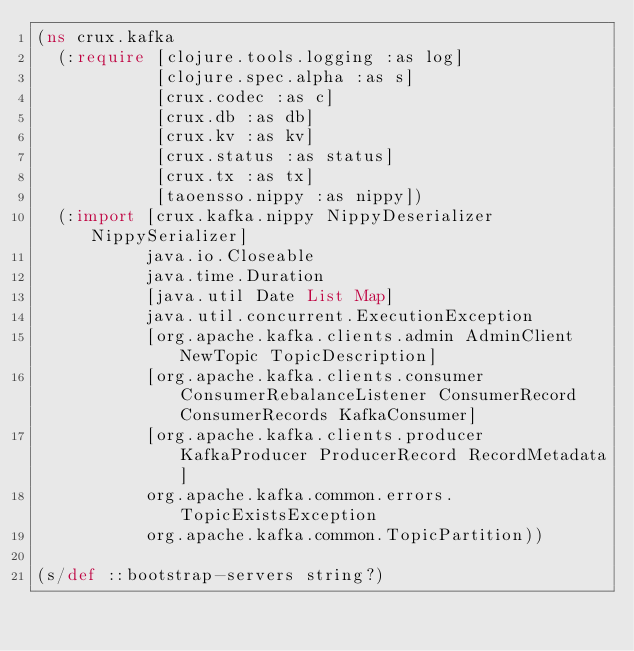Convert code to text. <code><loc_0><loc_0><loc_500><loc_500><_Clojure_>(ns crux.kafka
  (:require [clojure.tools.logging :as log]
            [clojure.spec.alpha :as s]
            [crux.codec :as c]
            [crux.db :as db]
            [crux.kv :as kv]
            [crux.status :as status]
            [crux.tx :as tx]
            [taoensso.nippy :as nippy])
  (:import [crux.kafka.nippy NippyDeserializer NippySerializer]
           java.io.Closeable
           java.time.Duration
           [java.util Date List Map]
           java.util.concurrent.ExecutionException
           [org.apache.kafka.clients.admin AdminClient NewTopic TopicDescription]
           [org.apache.kafka.clients.consumer ConsumerRebalanceListener ConsumerRecord ConsumerRecords KafkaConsumer]
           [org.apache.kafka.clients.producer KafkaProducer ProducerRecord RecordMetadata]
           org.apache.kafka.common.errors.TopicExistsException
           org.apache.kafka.common.TopicPartition))

(s/def ::bootstrap-servers string?)</code> 